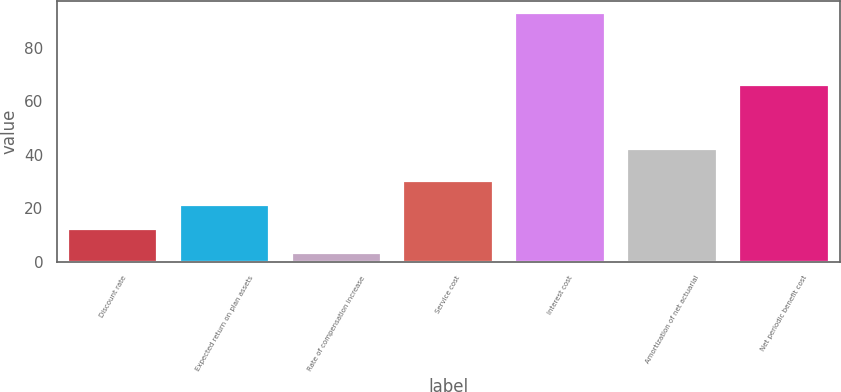Convert chart to OTSL. <chart><loc_0><loc_0><loc_500><loc_500><bar_chart><fcel>Discount rate<fcel>Expected return on plan assets<fcel>Rate of compensation increase<fcel>Service cost<fcel>Interest cost<fcel>Amortization of net actuarial<fcel>Net periodic benefit cost<nl><fcel>12.22<fcel>21.2<fcel>3.25<fcel>30.17<fcel>93<fcel>42<fcel>66<nl></chart> 